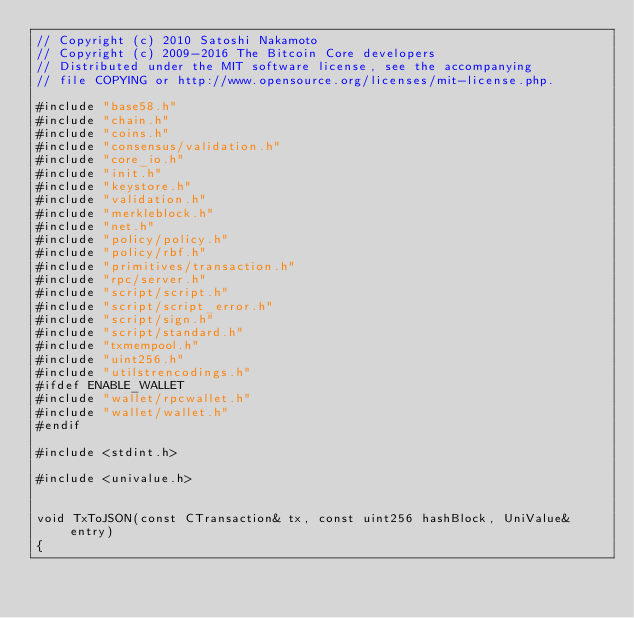Convert code to text. <code><loc_0><loc_0><loc_500><loc_500><_C++_>// Copyright (c) 2010 Satoshi Nakamoto
// Copyright (c) 2009-2016 The Bitcoin Core developers
// Distributed under the MIT software license, see the accompanying
// file COPYING or http://www.opensource.org/licenses/mit-license.php.

#include "base58.h"
#include "chain.h"
#include "coins.h"
#include "consensus/validation.h"
#include "core_io.h"
#include "init.h"
#include "keystore.h"
#include "validation.h"
#include "merkleblock.h"
#include "net.h"
#include "policy/policy.h"
#include "policy/rbf.h"
#include "primitives/transaction.h"
#include "rpc/server.h"
#include "script/script.h"
#include "script/script_error.h"
#include "script/sign.h"
#include "script/standard.h"
#include "txmempool.h"
#include "uint256.h"
#include "utilstrencodings.h"
#ifdef ENABLE_WALLET
#include "wallet/rpcwallet.h"
#include "wallet/wallet.h"
#endif

#include <stdint.h>

#include <univalue.h>


void TxToJSON(const CTransaction& tx, const uint256 hashBlock, UniValue& entry)
{</code> 